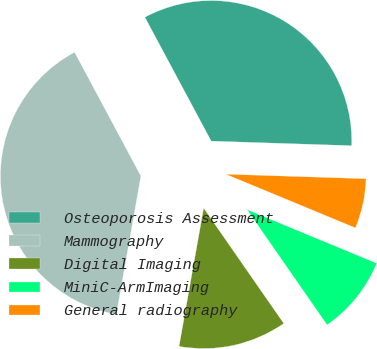Convert chart to OTSL. <chart><loc_0><loc_0><loc_500><loc_500><pie_chart><fcel>Osteoporosis Assessment<fcel>Mammography<fcel>Digital Imaging<fcel>MiniC-ArmImaging<fcel>General radiography<nl><fcel>33.34%<fcel>39.37%<fcel>12.46%<fcel>9.09%<fcel>5.73%<nl></chart> 